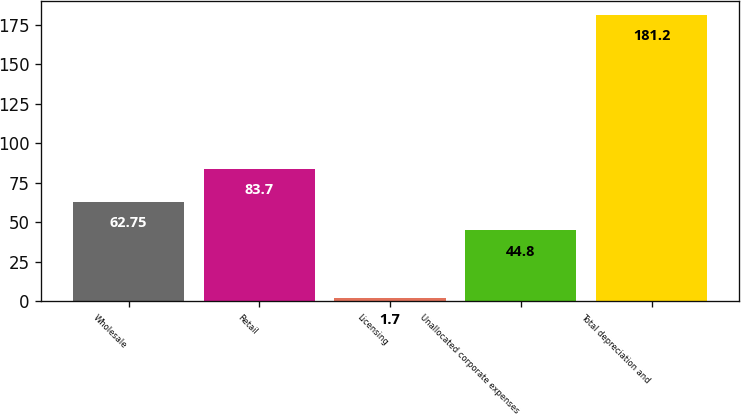Convert chart. <chart><loc_0><loc_0><loc_500><loc_500><bar_chart><fcel>Wholesale<fcel>Retail<fcel>Licensing<fcel>Unallocated corporate expenses<fcel>Total depreciation and<nl><fcel>62.75<fcel>83.7<fcel>1.7<fcel>44.8<fcel>181.2<nl></chart> 